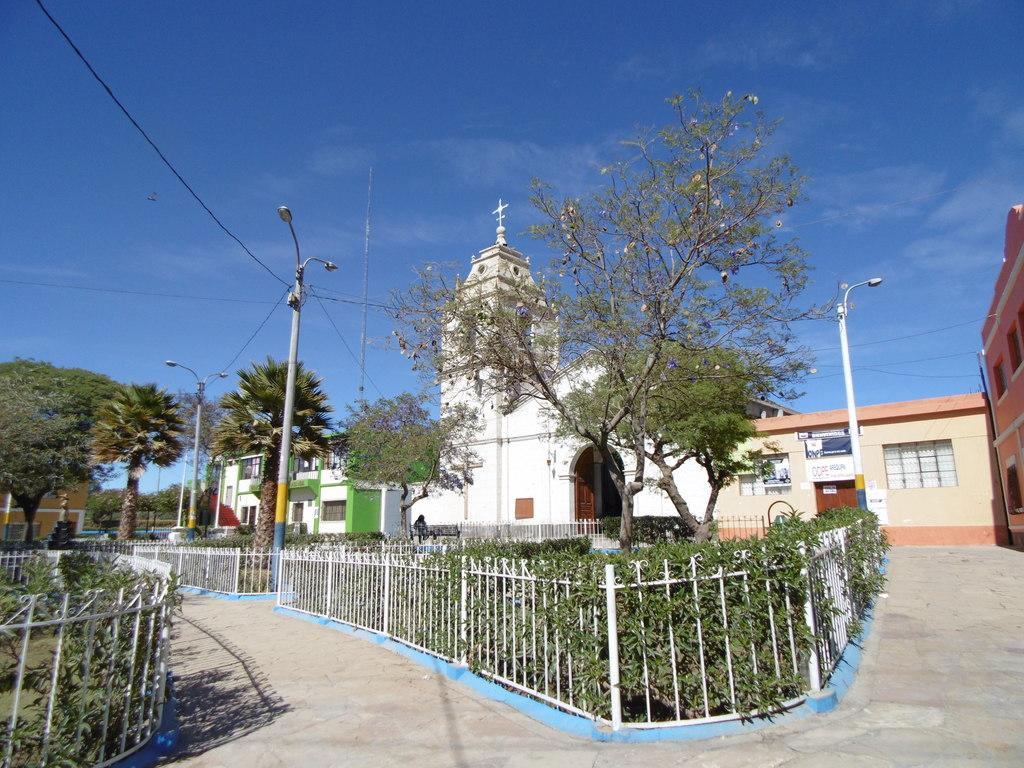What type of structures can be seen in the image? There are houses in the image. What else can be seen in the image besides houses? There are poles, trees, walls, windows, plants, grills, and walkways in the image. Can you describe the natural elements present in the image? There are trees and plants in the image. What is visible in the background of the image? The sky is visible in the background of the image. What type of bell can be heard ringing in the image? There is no bell present in the image, and therefore no sound can be heard. What is the wrist doing in the image? There is no wrist visible in the image. 